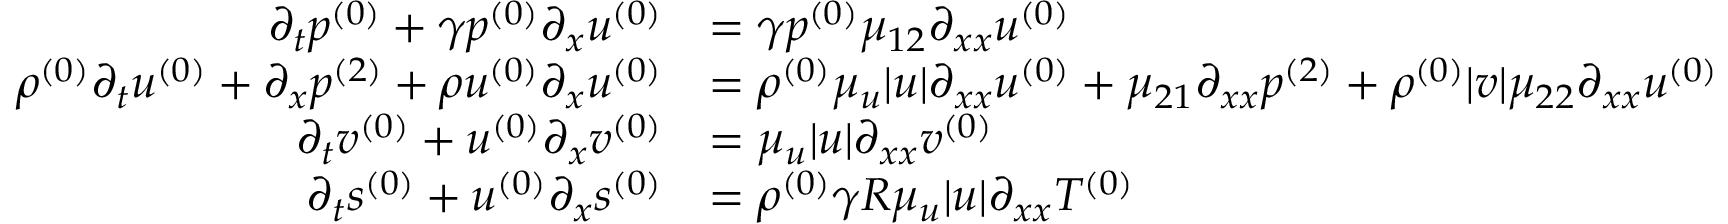<formula> <loc_0><loc_0><loc_500><loc_500>\begin{array} { r l } { \partial _ { t } { p ^ { ( 0 ) } } + \gamma { p ^ { ( 0 ) } } \partial _ { x } { u ^ { ( 0 ) } } } & { = \gamma { p ^ { ( 0 ) } } \mu _ { 1 2 } \partial _ { x x } { u ^ { ( 0 ) } } } \\ { { \rho ^ { ( 0 ) } } \partial _ { t } { u ^ { ( 0 ) } } + \partial _ { x } { p ^ { ( 2 ) } } + { \rho u ^ { ( 0 ) } } \partial _ { x } { u ^ { ( 0 ) } } } & { = { \rho ^ { ( 0 ) } } \mu _ { u } | u | \partial _ { x x } { u ^ { ( 0 ) } } + \mu _ { 2 1 } \partial _ { x x } { p ^ { ( 2 ) } } + { \rho ^ { ( 0 ) } } | v | \mu _ { 2 2 } \partial _ { x x } { u ^ { ( 0 ) } } } \\ { \partial _ { t } { v ^ { ( 0 ) } } + { u ^ { ( 0 ) } } \partial _ { x } { v ^ { ( 0 ) } } } & { = \mu _ { u } | u | \partial _ { x x } { v ^ { ( 0 ) } } } \\ { \partial _ { t } { s ^ { ( 0 ) } } + { u ^ { ( 0 ) } } \partial _ { x } { s ^ { ( 0 ) } } } & { = { \rho ^ { ( 0 ) } } \gamma R \mu _ { u } | u | \partial _ { x x } { T ^ { ( 0 ) } } } \end{array}</formula> 